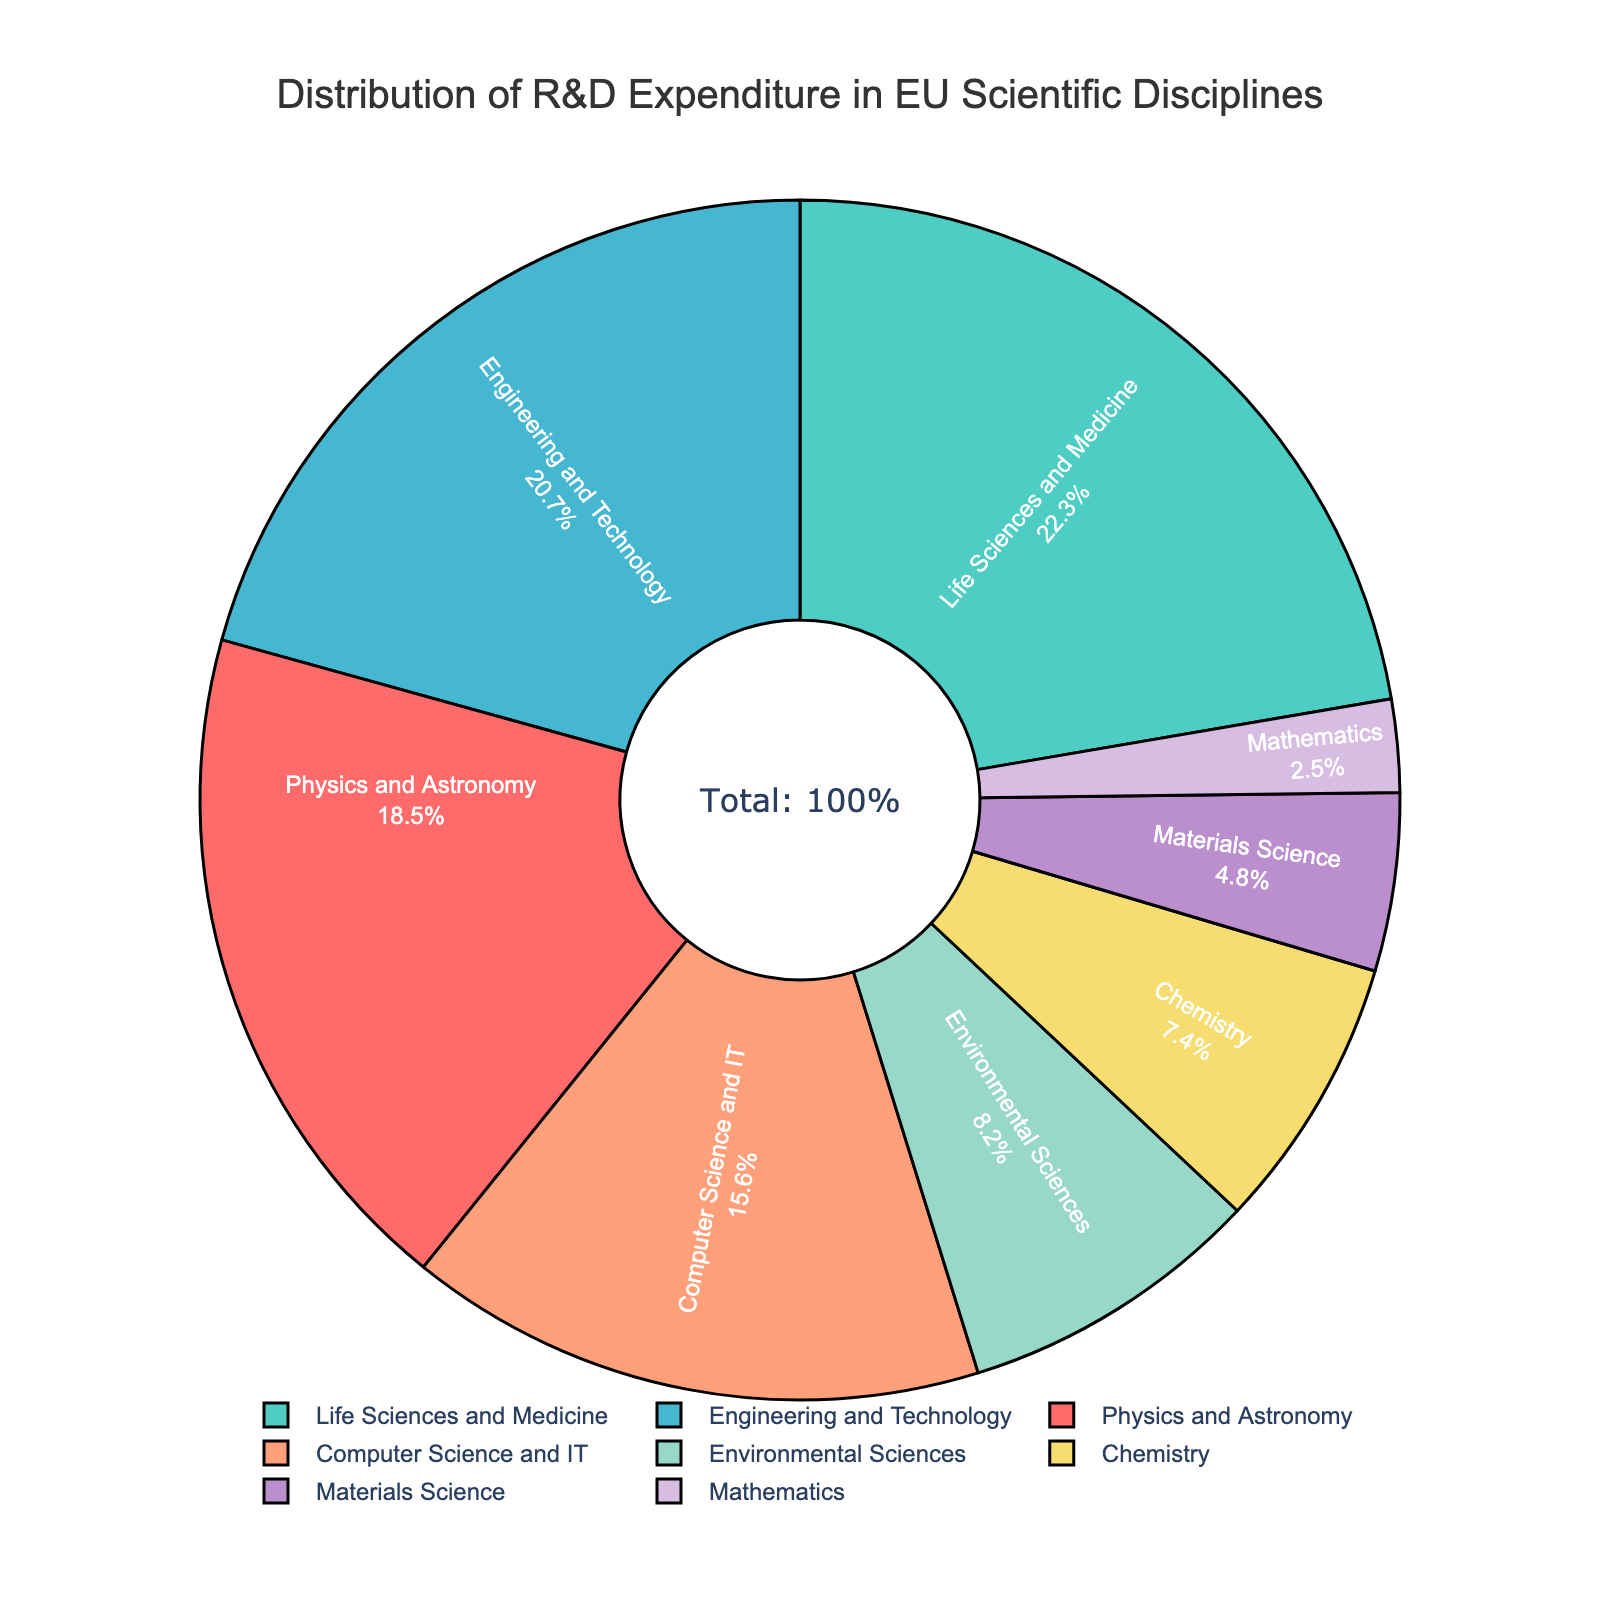Which two disciplines together cover the largest portion of R&D expenditure? First, identify the two disciplines with the highest percentages: 'Life Sciences and Medicine' (22.3%) and 'Engineering and Technology' (20.7%). Summing these values gives 22.3% + 20.7% = 43%.
Answer: Life Sciences and Medicine, Engineering and Technology What is the percentage difference between Engineering and Technology and Computer Science and IT? Subtract the percentage of 'Computer Science and IT' (15.6%) from 'Engineering and Technology' (20.7%): 20.7% - 15.6% = 5.1%.
Answer: 5.1% What is the combined percentage of Environmental Sciences and Mathematics? Add the percentages of 'Environmental Sciences' (8.2%) and 'Mathematics' (2.5%): 8.2% + 2.5% = 10.7%.
Answer: 10.7% Which discipline occupies approximately the same percentage as Chemistry? From the chart, 'Materials Science' (4.8%) is the closest to 'Chemistry' (7.4%).
Answer: Materials Science Which discipline is represented by the red color? Each color in the pie chart is associated with a label. According to the first color in the custom color palette (#FF6B6B, which is red), this corresponds to 'Physics and Astronomy' (18.5%).
Answer: Physics and Astronomy Is the allocation for Life Sciences and Medicine more than double that of Mathematics? Compare the percentages of 'Life Sciences and Medicine' (22.3%) and 'Mathematics' (2.5%). More than double Mathematics would be 2.5% * 2 = 5%. Since 22.3% > 5%, the statement is true.
Answer: Yes How much more is the expenditure on Physical Sciences (Physics and Astronomy) compared to Materials Science? Subtract 'Materials Science' (4.8%) from 'Physics and Astronomy' (18.5%): 18.5% - 4.8% = 13.7%.
Answer: 13.7% What is the percentage allocation for disciplines that are not part of STEM (Science, Technology, Engineering, Mathematics)? Exclude the STEM categories: 'Physics and Astronomy', 'Engineering and Technology', 'Computer Science and IT', 'Chemistry', 'Materials Science', 'Mathematics'. The remaining disciplines: 'Life Sciences and Medicine' (22.3%) + 'Environmental Sciences' (8.2%) = 30.5%.
Answer: 30.5% 